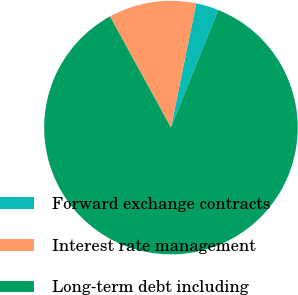Convert chart. <chart><loc_0><loc_0><loc_500><loc_500><pie_chart><fcel>Forward exchange contracts<fcel>Interest rate management<fcel>Long-term debt including<nl><fcel>2.88%<fcel>11.19%<fcel>85.93%<nl></chart> 